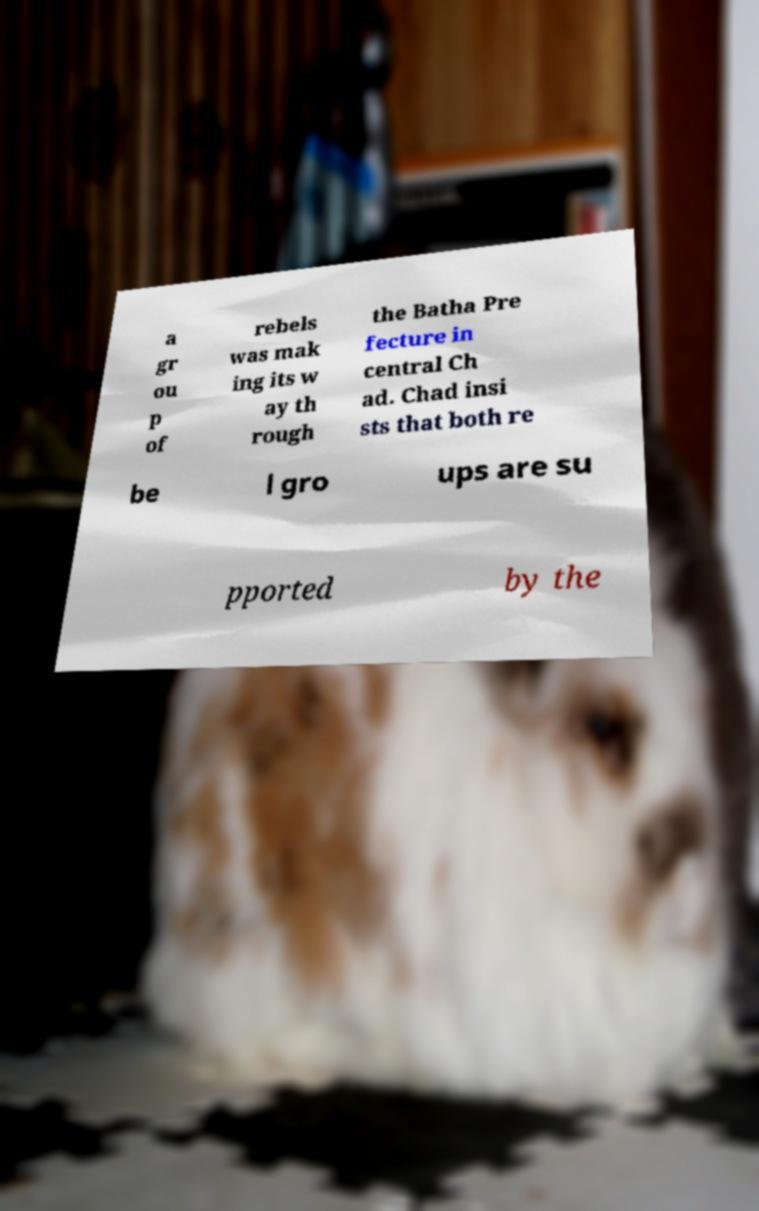Please identify and transcribe the text found in this image. a gr ou p of rebels was mak ing its w ay th rough the Batha Pre fecture in central Ch ad. Chad insi sts that both re be l gro ups are su pported by the 